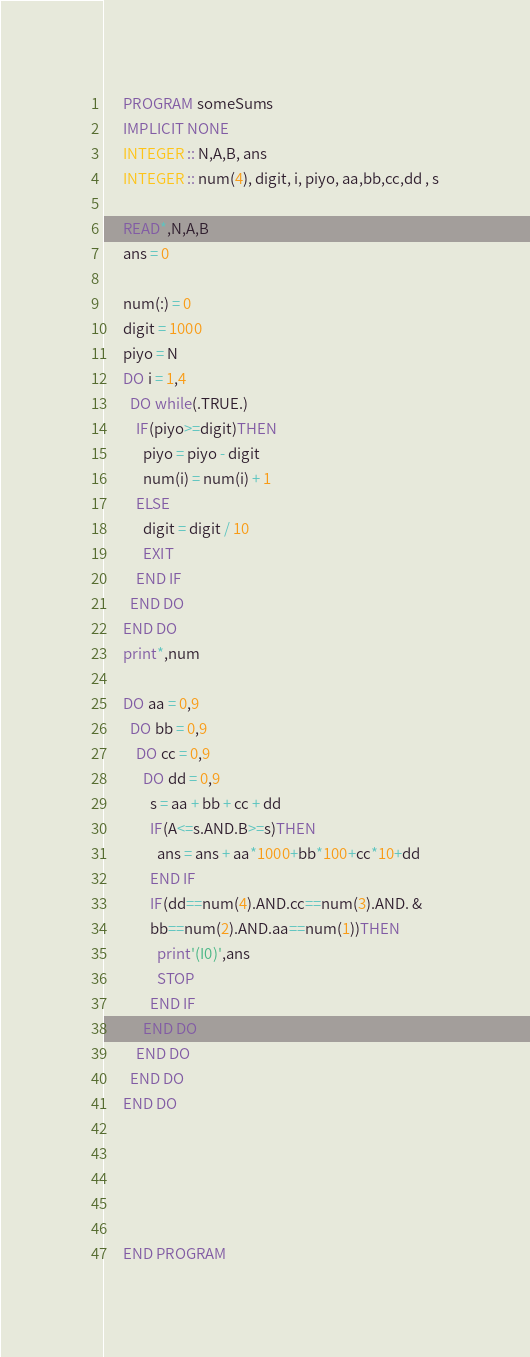Convert code to text. <code><loc_0><loc_0><loc_500><loc_500><_FORTRAN_>      PROGRAM someSums
      IMPLICIT NONE
      INTEGER :: N,A,B, ans
      INTEGER :: num(4), digit, i, piyo, aa,bb,cc,dd , s
      
      READ*,N,A,B
      ans = 0
      
      num(:) = 0
      digit = 1000
      piyo = N
      DO i = 1,4
        DO while(.TRUE.)
          IF(piyo>=digit)THEN
            piyo = piyo - digit
            num(i) = num(i) + 1
          ELSE
            digit = digit / 10
            EXIT
          END IF
        END DO
      END DO
      print*,num
      
      DO aa = 0,9
        DO bb = 0,9
          DO cc = 0,9
            DO dd = 0,9
              s = aa + bb + cc + dd
              IF(A<=s.AND.B>=s)THEN
                ans = ans + aa*1000+bb*100+cc*10+dd
              END IF
              IF(dd==num(4).AND.cc==num(3).AND. &
              bb==num(2).AND.aa==num(1))THEN
                print'(I0)',ans
                STOP
              END IF
            END DO
          END DO
        END DO
      END DO
      
      
      
      
      
      END PROGRAM</code> 